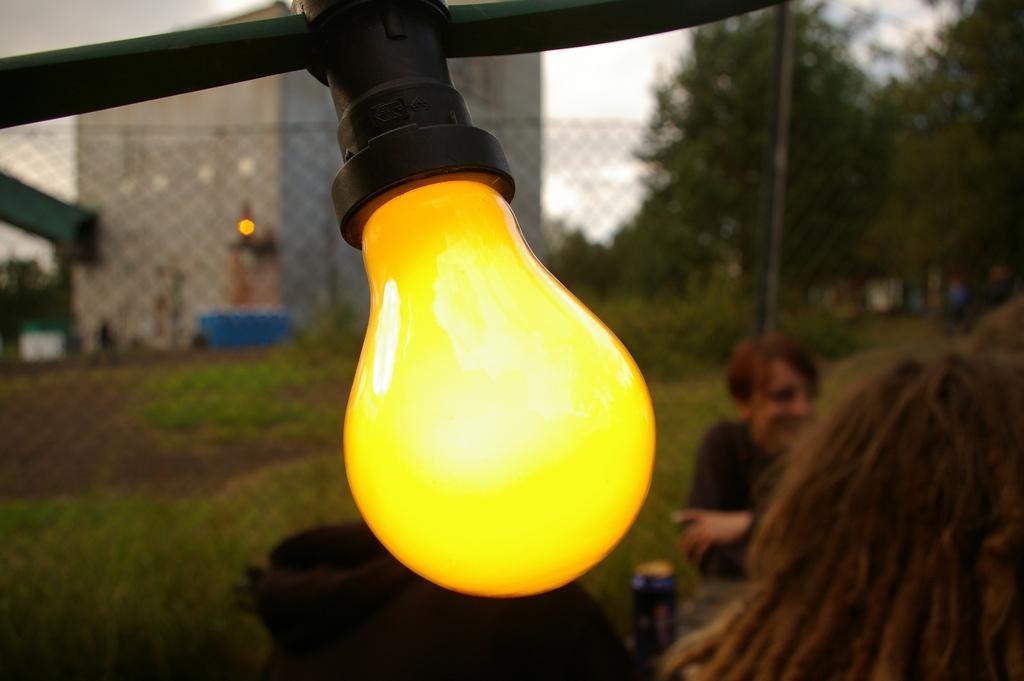In one or two sentences, can you explain what this image depicts? In this image, we can see a light bulb, there are some people sitting, we can see the fence, there are some trees, we can see a building, we can see the sky. 